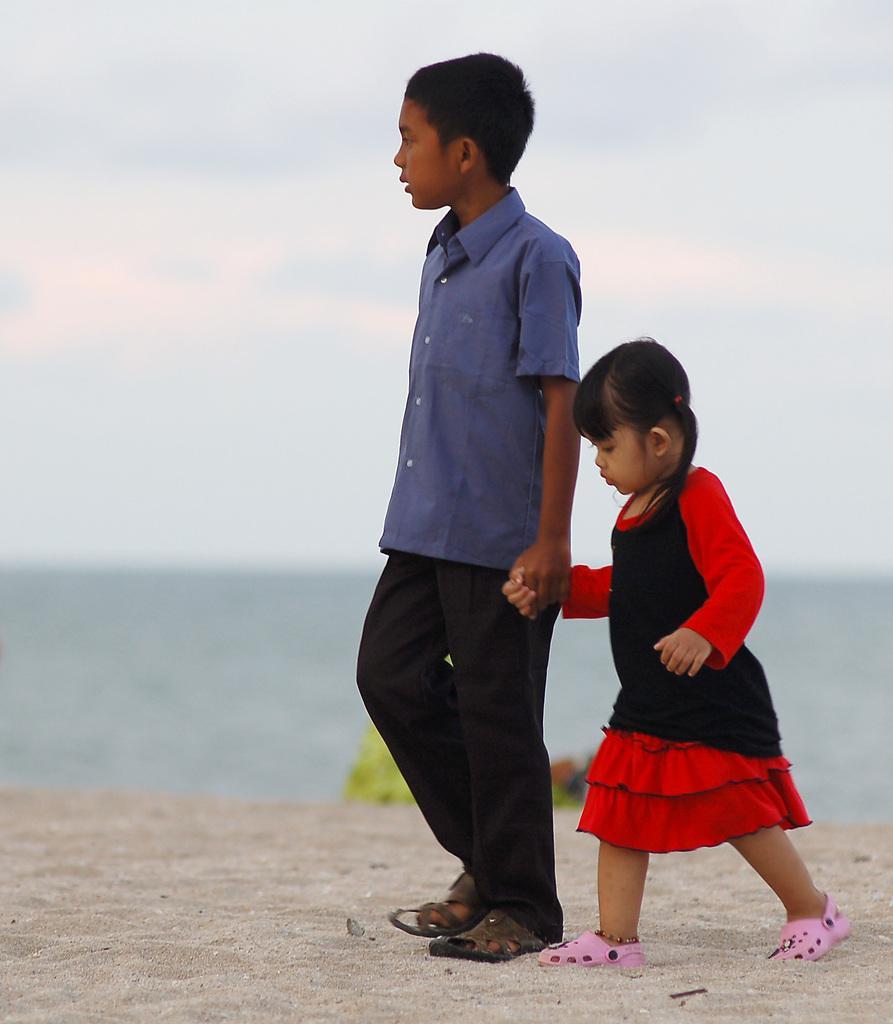Could you give a brief overview of what you see in this image? There are two kids standing and holding each other and there are water in the background. 